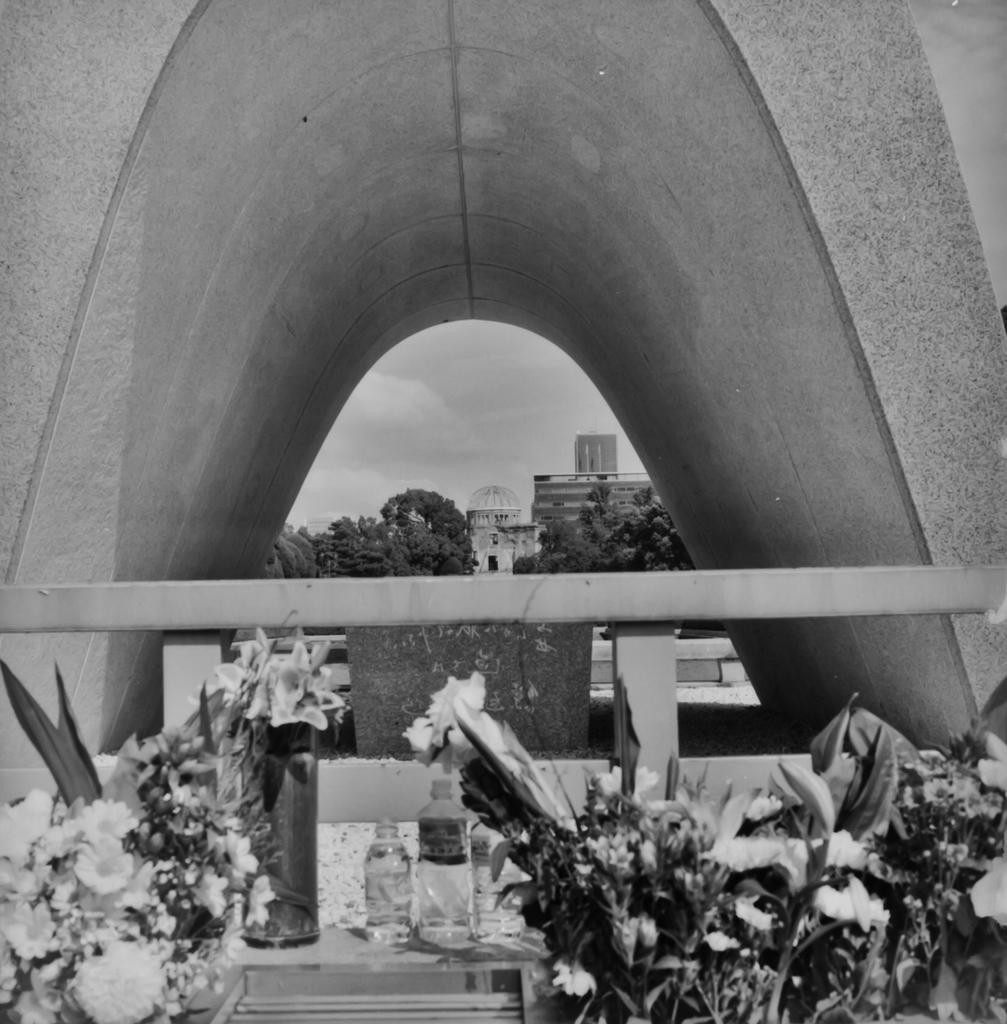What type of vegetation is visible in the front of the image? There are plants in the front of the image. What can be seen in the background of the image? There are trees and buildings in the background of the image. What is the condition of the sky in the image? The sky is cloudy in the image. What structure is located in the center of the image? There is an arch in the center of the image. What objects are present in the image? There are bottles present in the image. How does the image depict the process of sleep? The image does not depict the process of sleep; it features plants, trees, buildings, a cloudy sky, an arch, and bottles. What type of throat condition can be seen in the image? There is no throat condition present in the image. 